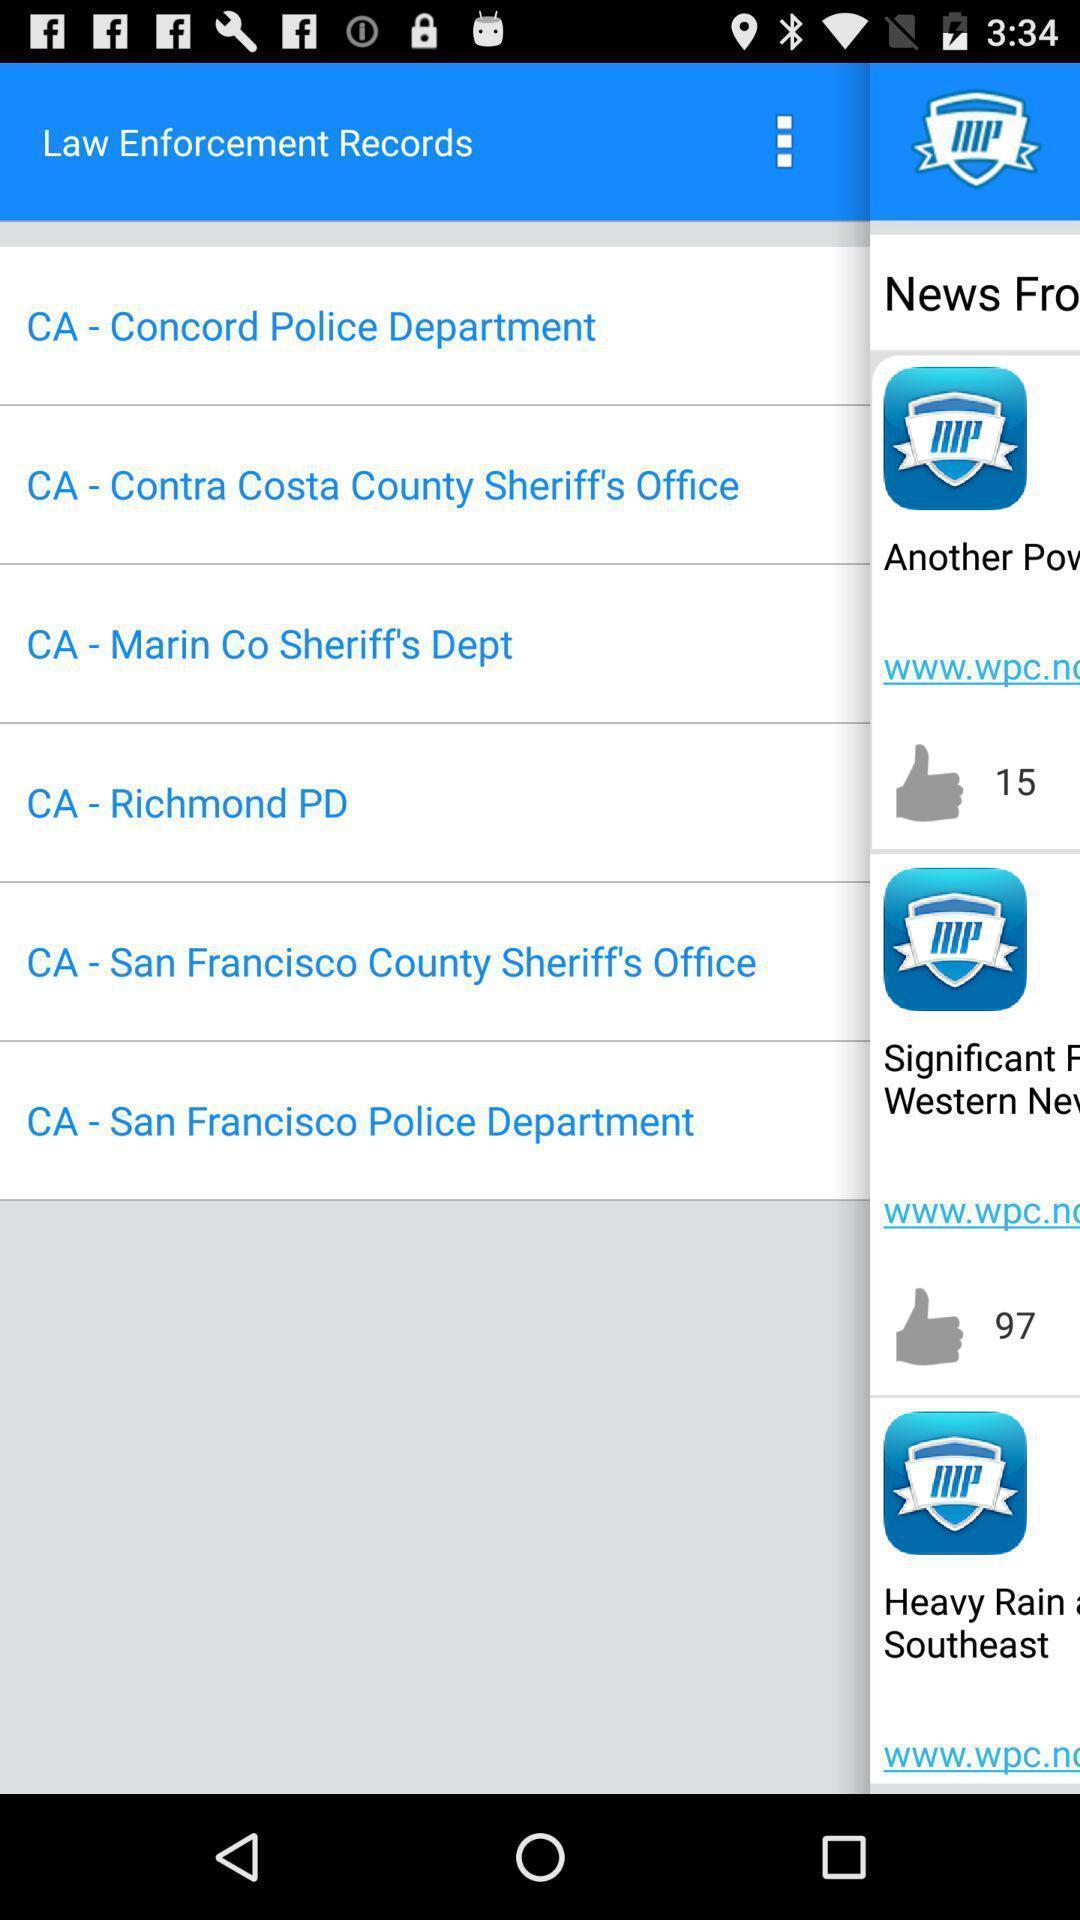Describe this image in words. Page displaying various laws. 